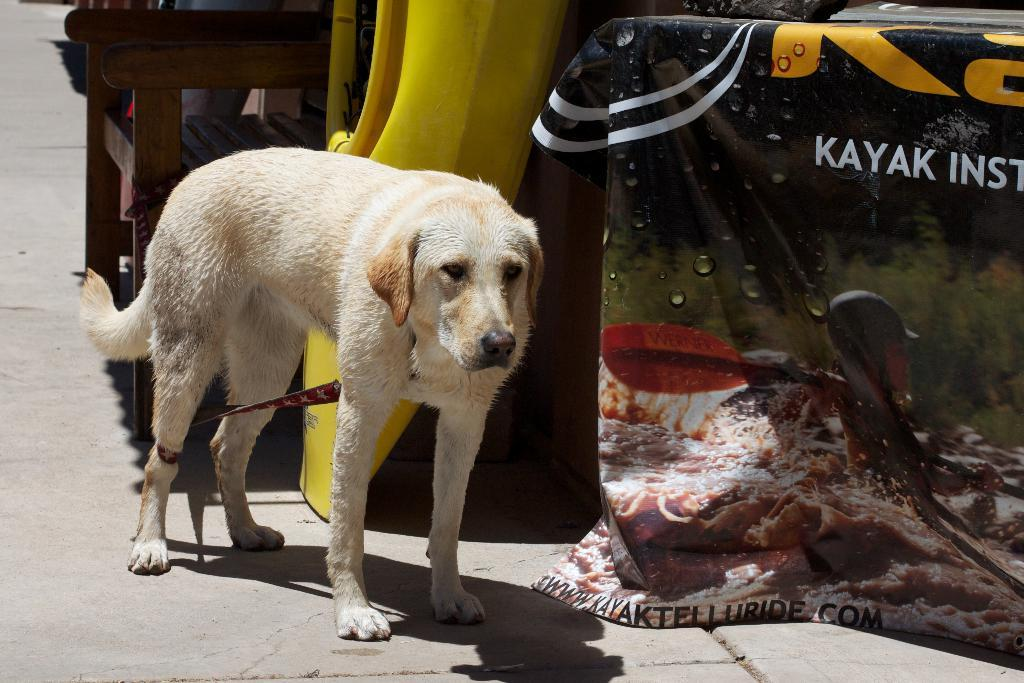What type of animal is in the image? There is a dog in the image. Where is the dog located in the image? The dog is standing on the floor. What can be seen in the background of the image? There is a chair and an advertisement. What type of cake is being used to cover the dog's shame in the image? There is no cake or indication of shame present in the image; it features a dog standing on the floor with a chair and an advertisement in the background. 